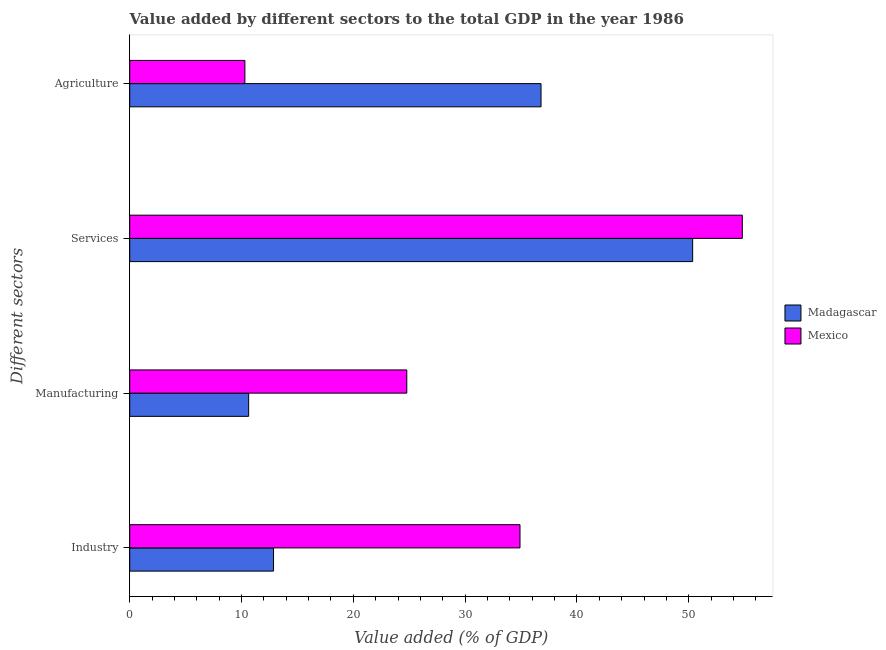How many different coloured bars are there?
Your response must be concise. 2. How many groups of bars are there?
Keep it short and to the point. 4. Are the number of bars per tick equal to the number of legend labels?
Ensure brevity in your answer.  Yes. Are the number of bars on each tick of the Y-axis equal?
Make the answer very short. Yes. What is the label of the 2nd group of bars from the top?
Your response must be concise. Services. What is the value added by agricultural sector in Madagascar?
Provide a succinct answer. 36.79. Across all countries, what is the maximum value added by manufacturing sector?
Your answer should be compact. 24.78. Across all countries, what is the minimum value added by agricultural sector?
Your answer should be very brief. 10.3. In which country was the value added by services sector maximum?
Your answer should be compact. Mexico. In which country was the value added by agricultural sector minimum?
Provide a short and direct response. Mexico. What is the total value added by agricultural sector in the graph?
Ensure brevity in your answer.  47.09. What is the difference between the value added by industrial sector in Madagascar and that in Mexico?
Offer a terse response. -22.05. What is the difference between the value added by manufacturing sector in Madagascar and the value added by agricultural sector in Mexico?
Your response must be concise. 0.34. What is the average value added by industrial sector per country?
Offer a very short reply. 23.88. What is the difference between the value added by industrial sector and value added by agricultural sector in Madagascar?
Provide a succinct answer. -23.93. In how many countries, is the value added by industrial sector greater than 12 %?
Give a very brief answer. 2. What is the ratio of the value added by services sector in Madagascar to that in Mexico?
Provide a succinct answer. 0.92. Is the difference between the value added by agricultural sector in Madagascar and Mexico greater than the difference between the value added by industrial sector in Madagascar and Mexico?
Your response must be concise. Yes. What is the difference between the highest and the second highest value added by manufacturing sector?
Provide a short and direct response. 14.14. What is the difference between the highest and the lowest value added by industrial sector?
Keep it short and to the point. 22.05. Is the sum of the value added by industrial sector in Madagascar and Mexico greater than the maximum value added by services sector across all countries?
Your answer should be very brief. No. What does the 1st bar from the top in Manufacturing represents?
Your response must be concise. Mexico. What does the 1st bar from the bottom in Services represents?
Your answer should be compact. Madagascar. Is it the case that in every country, the sum of the value added by industrial sector and value added by manufacturing sector is greater than the value added by services sector?
Give a very brief answer. No. Are all the bars in the graph horizontal?
Keep it short and to the point. Yes. Are the values on the major ticks of X-axis written in scientific E-notation?
Provide a short and direct response. No. Does the graph contain any zero values?
Make the answer very short. No. What is the title of the graph?
Offer a very short reply. Value added by different sectors to the total GDP in the year 1986. Does "Belgium" appear as one of the legend labels in the graph?
Give a very brief answer. No. What is the label or title of the X-axis?
Your answer should be very brief. Value added (% of GDP). What is the label or title of the Y-axis?
Provide a short and direct response. Different sectors. What is the Value added (% of GDP) in Madagascar in Industry?
Keep it short and to the point. 12.86. What is the Value added (% of GDP) in Mexico in Industry?
Provide a succinct answer. 34.91. What is the Value added (% of GDP) of Madagascar in Manufacturing?
Ensure brevity in your answer.  10.64. What is the Value added (% of GDP) in Mexico in Manufacturing?
Your answer should be compact. 24.78. What is the Value added (% of GDP) in Madagascar in Services?
Give a very brief answer. 50.35. What is the Value added (% of GDP) of Mexico in Services?
Make the answer very short. 54.79. What is the Value added (% of GDP) in Madagascar in Agriculture?
Your answer should be very brief. 36.79. What is the Value added (% of GDP) in Mexico in Agriculture?
Make the answer very short. 10.3. Across all Different sectors, what is the maximum Value added (% of GDP) in Madagascar?
Your answer should be very brief. 50.35. Across all Different sectors, what is the maximum Value added (% of GDP) in Mexico?
Your answer should be very brief. 54.79. Across all Different sectors, what is the minimum Value added (% of GDP) in Madagascar?
Your answer should be very brief. 10.64. Across all Different sectors, what is the minimum Value added (% of GDP) in Mexico?
Provide a succinct answer. 10.3. What is the total Value added (% of GDP) of Madagascar in the graph?
Provide a short and direct response. 110.64. What is the total Value added (% of GDP) in Mexico in the graph?
Your answer should be compact. 124.78. What is the difference between the Value added (% of GDP) of Madagascar in Industry and that in Manufacturing?
Ensure brevity in your answer.  2.23. What is the difference between the Value added (% of GDP) of Mexico in Industry and that in Manufacturing?
Ensure brevity in your answer.  10.13. What is the difference between the Value added (% of GDP) of Madagascar in Industry and that in Services?
Your answer should be very brief. -37.49. What is the difference between the Value added (% of GDP) in Mexico in Industry and that in Services?
Offer a very short reply. -19.88. What is the difference between the Value added (% of GDP) of Madagascar in Industry and that in Agriculture?
Keep it short and to the point. -23.93. What is the difference between the Value added (% of GDP) in Mexico in Industry and that in Agriculture?
Give a very brief answer. 24.61. What is the difference between the Value added (% of GDP) in Madagascar in Manufacturing and that in Services?
Your answer should be compact. -39.71. What is the difference between the Value added (% of GDP) in Mexico in Manufacturing and that in Services?
Ensure brevity in your answer.  -30.01. What is the difference between the Value added (% of GDP) of Madagascar in Manufacturing and that in Agriculture?
Ensure brevity in your answer.  -26.15. What is the difference between the Value added (% of GDP) of Mexico in Manufacturing and that in Agriculture?
Offer a very short reply. 14.48. What is the difference between the Value added (% of GDP) in Madagascar in Services and that in Agriculture?
Provide a short and direct response. 13.56. What is the difference between the Value added (% of GDP) in Mexico in Services and that in Agriculture?
Provide a succinct answer. 44.49. What is the difference between the Value added (% of GDP) of Madagascar in Industry and the Value added (% of GDP) of Mexico in Manufacturing?
Give a very brief answer. -11.92. What is the difference between the Value added (% of GDP) in Madagascar in Industry and the Value added (% of GDP) in Mexico in Services?
Offer a terse response. -41.93. What is the difference between the Value added (% of GDP) of Madagascar in Industry and the Value added (% of GDP) of Mexico in Agriculture?
Make the answer very short. 2.56. What is the difference between the Value added (% of GDP) in Madagascar in Manufacturing and the Value added (% of GDP) in Mexico in Services?
Provide a succinct answer. -44.16. What is the difference between the Value added (% of GDP) of Madagascar in Manufacturing and the Value added (% of GDP) of Mexico in Agriculture?
Your answer should be compact. 0.34. What is the difference between the Value added (% of GDP) of Madagascar in Services and the Value added (% of GDP) of Mexico in Agriculture?
Provide a succinct answer. 40.05. What is the average Value added (% of GDP) in Madagascar per Different sectors?
Provide a short and direct response. 27.66. What is the average Value added (% of GDP) in Mexico per Different sectors?
Ensure brevity in your answer.  31.2. What is the difference between the Value added (% of GDP) of Madagascar and Value added (% of GDP) of Mexico in Industry?
Keep it short and to the point. -22.05. What is the difference between the Value added (% of GDP) of Madagascar and Value added (% of GDP) of Mexico in Manufacturing?
Provide a short and direct response. -14.14. What is the difference between the Value added (% of GDP) of Madagascar and Value added (% of GDP) of Mexico in Services?
Ensure brevity in your answer.  -4.44. What is the difference between the Value added (% of GDP) of Madagascar and Value added (% of GDP) of Mexico in Agriculture?
Your response must be concise. 26.49. What is the ratio of the Value added (% of GDP) of Madagascar in Industry to that in Manufacturing?
Keep it short and to the point. 1.21. What is the ratio of the Value added (% of GDP) of Mexico in Industry to that in Manufacturing?
Make the answer very short. 1.41. What is the ratio of the Value added (% of GDP) in Madagascar in Industry to that in Services?
Offer a terse response. 0.26. What is the ratio of the Value added (% of GDP) of Mexico in Industry to that in Services?
Make the answer very short. 0.64. What is the ratio of the Value added (% of GDP) in Madagascar in Industry to that in Agriculture?
Ensure brevity in your answer.  0.35. What is the ratio of the Value added (% of GDP) of Mexico in Industry to that in Agriculture?
Keep it short and to the point. 3.39. What is the ratio of the Value added (% of GDP) of Madagascar in Manufacturing to that in Services?
Your answer should be very brief. 0.21. What is the ratio of the Value added (% of GDP) in Mexico in Manufacturing to that in Services?
Give a very brief answer. 0.45. What is the ratio of the Value added (% of GDP) of Madagascar in Manufacturing to that in Agriculture?
Your answer should be compact. 0.29. What is the ratio of the Value added (% of GDP) of Mexico in Manufacturing to that in Agriculture?
Your answer should be compact. 2.41. What is the ratio of the Value added (% of GDP) in Madagascar in Services to that in Agriculture?
Give a very brief answer. 1.37. What is the ratio of the Value added (% of GDP) in Mexico in Services to that in Agriculture?
Make the answer very short. 5.32. What is the difference between the highest and the second highest Value added (% of GDP) in Madagascar?
Your response must be concise. 13.56. What is the difference between the highest and the second highest Value added (% of GDP) of Mexico?
Your answer should be very brief. 19.88. What is the difference between the highest and the lowest Value added (% of GDP) of Madagascar?
Keep it short and to the point. 39.71. What is the difference between the highest and the lowest Value added (% of GDP) of Mexico?
Make the answer very short. 44.49. 